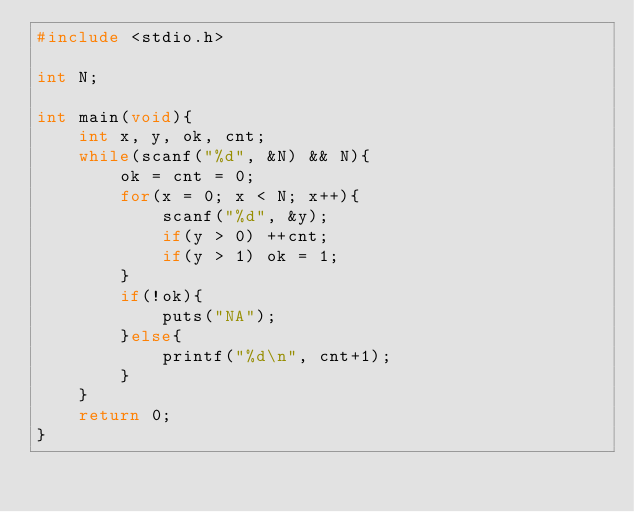Convert code to text. <code><loc_0><loc_0><loc_500><loc_500><_C_>#include <stdio.h>

int N;

int main(void){
    int x, y, ok, cnt;
    while(scanf("%d", &N) && N){
        ok = cnt = 0;
        for(x = 0; x < N; x++){
            scanf("%d", &y);
            if(y > 0) ++cnt;
            if(y > 1) ok = 1;
        }
        if(!ok){
            puts("NA");
        }else{
            printf("%d\n", cnt+1);
        }
    }
    return 0;
}</code> 